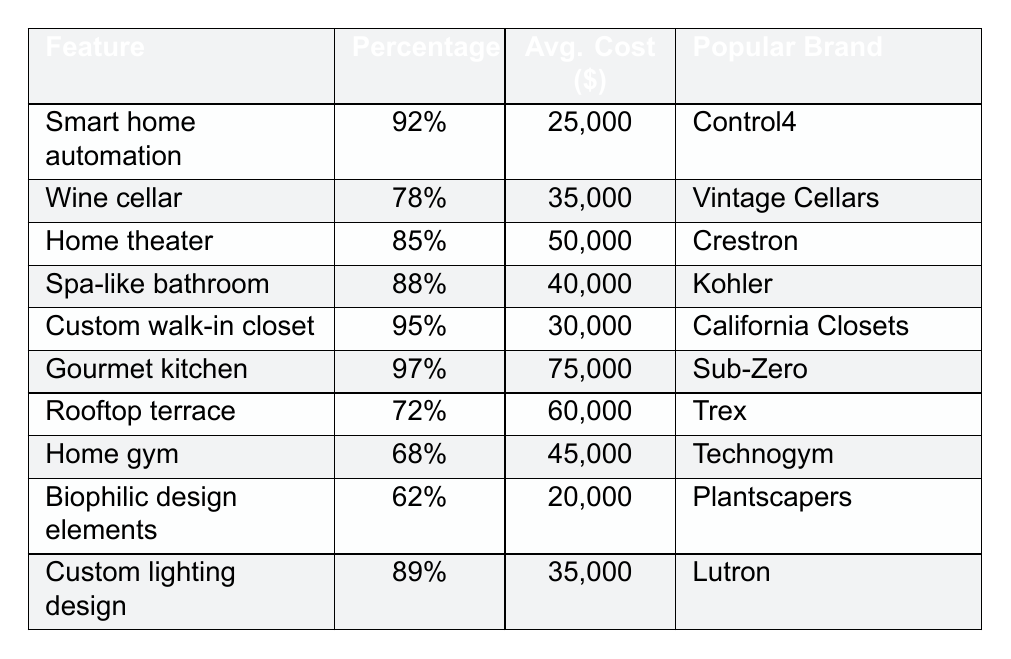What is the most requested custom design feature in high-end urban residences? The feature with the highest percentage in the table is "Gourmet kitchen," which has a percentage of 97%.
Answer: Gourmet kitchen Which custom design feature has the lowest average cost? The feature with the lowest average cost is "Biophilic design elements," which costs $20,000.
Answer: $20,000 How much more does a "Home theater" cost on average compared to a "Custom walk-in closet"? The average cost of a "Home theater" is $50,000 whereas for a "Custom walk-in closet" it is $30,000. The difference is $50,000 - $30,000 = $20,000.
Answer: $20,000 Is "Smart home automation" more popular than "Custom lighting design"? Yes, "Smart home automation" has a popularity percentage of 92%, while "Custom lighting design" has a percentage of 89%.
Answer: Yes What is the average percentage popularity of all the features listed in the table? First, add all the percentages: 92 + 78 + 85 + 88 + 95 + 97 + 72 + 68 + 62 + 89 =  934. There are 10 features, so the average is 934/10 = 93.4%.
Answer: 93.4% How many features have an average cost of over $40,000? The features with costs over $40,000 are "Home theater" ($50,000), "Spa-like bathroom" ($40,000), "Rooftop terrace" ($60,000), "Home gym" ($45,000), and "Gourmet kitchen" ($75,000). There are 5 such features.
Answer: 5 Which brand is associated with the "Wine cellar"? The popular brand for the "Wine cellar" feature is "Vintage Cellars."
Answer: Vintage Cellars Can we find a feature that has both high popularity and a relatively low cost? Yes, "Spa-like bathroom" has a popularity of 88% and an average cost of $40,000, which is one of the lower costs in the range of features with high popularity.
Answer: Yes, "Spa-like bathroom" What is the most expensive feature on the list? The "Gourmet kitchen" is the most expensive feature, with an average cost of $75,000.
Answer: $75,000 Which feature has a lower popularity: "Home gym" or "Biophilic design elements"? "Home gym" has a popularity of 68%, while "Biophilic design elements" has a popularity of 62%. Therefore, "Biophilic design elements" is lower in popularity.
Answer: Biophilic design elements 